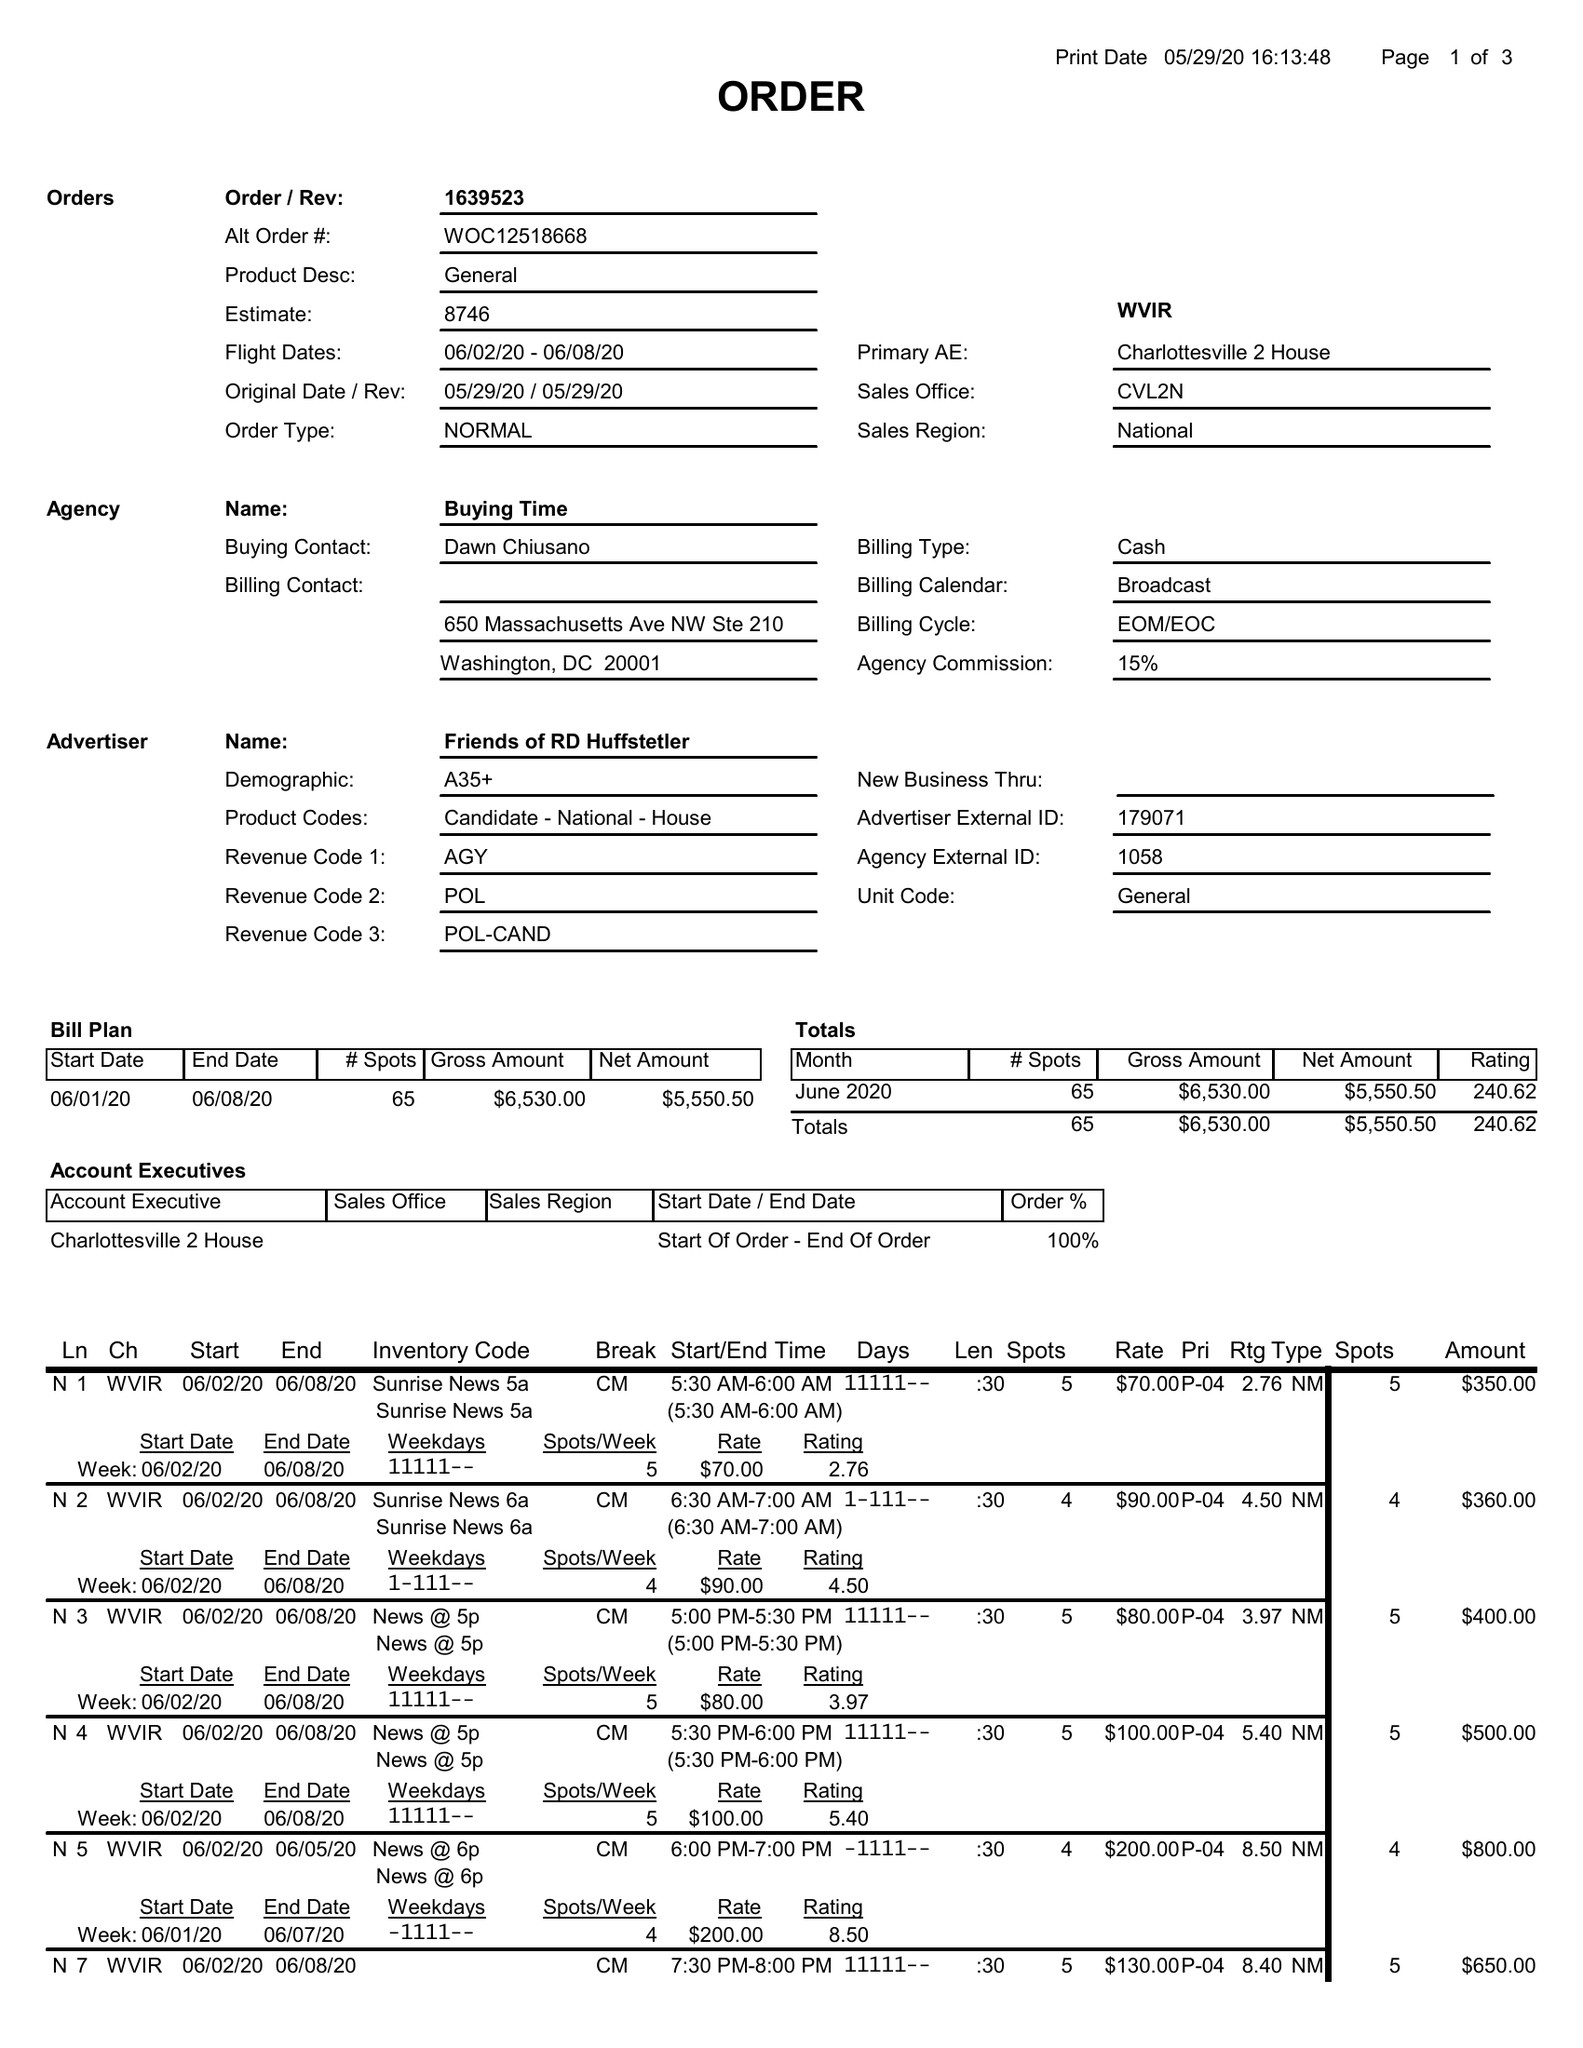What is the value for the flight_from?
Answer the question using a single word or phrase. 06/02/20 